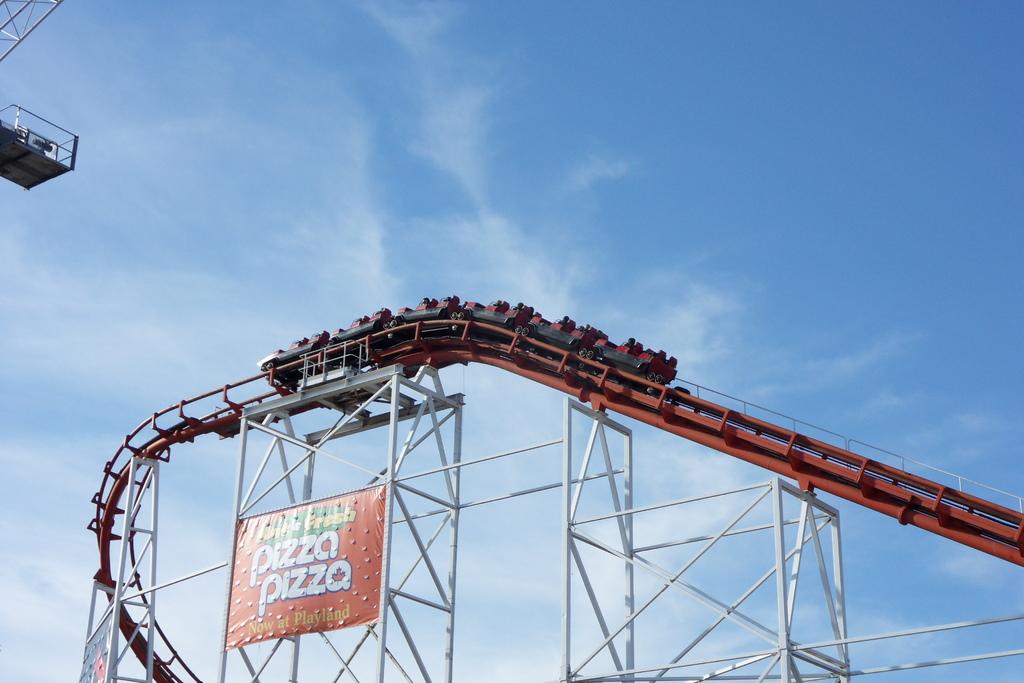What restaurant is in this theme park?
Your response must be concise. Pizza pizza. What does the restaurant serve?
Provide a short and direct response. Pizza. 